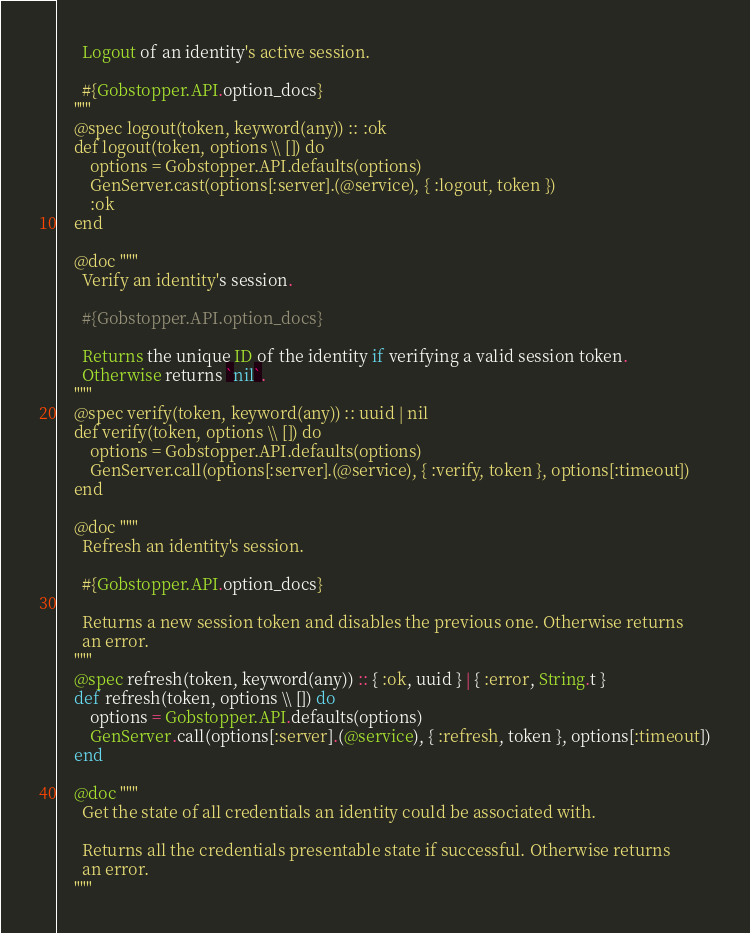Convert code to text. <code><loc_0><loc_0><loc_500><loc_500><_Elixir_>      Logout of an identity's active session.

      #{Gobstopper.API.option_docs}
    """
    @spec logout(token, keyword(any)) :: :ok
    def logout(token, options \\ []) do
        options = Gobstopper.API.defaults(options)
        GenServer.cast(options[:server].(@service), { :logout, token })
        :ok
    end

    @doc """
      Verify an identity's session.

      #{Gobstopper.API.option_docs}

      Returns the unique ID of the identity if verifying a valid session token.
      Otherwise returns `nil`.
    """
    @spec verify(token, keyword(any)) :: uuid | nil
    def verify(token, options \\ []) do
        options = Gobstopper.API.defaults(options)
        GenServer.call(options[:server].(@service), { :verify, token }, options[:timeout])
    end

    @doc """
      Refresh an identity's session.

      #{Gobstopper.API.option_docs}

      Returns a new session token and disables the previous one. Otherwise returns
      an error.
    """
    @spec refresh(token, keyword(any)) :: { :ok, uuid } | { :error, String.t }
    def refresh(token, options \\ []) do
        options = Gobstopper.API.defaults(options)
        GenServer.call(options[:server].(@service), { :refresh, token }, options[:timeout])
    end

    @doc """
      Get the state of all credentials an identity could be associated with.

      Returns all the credentials presentable state if successful. Otherwise returns
      an error.
    """</code> 